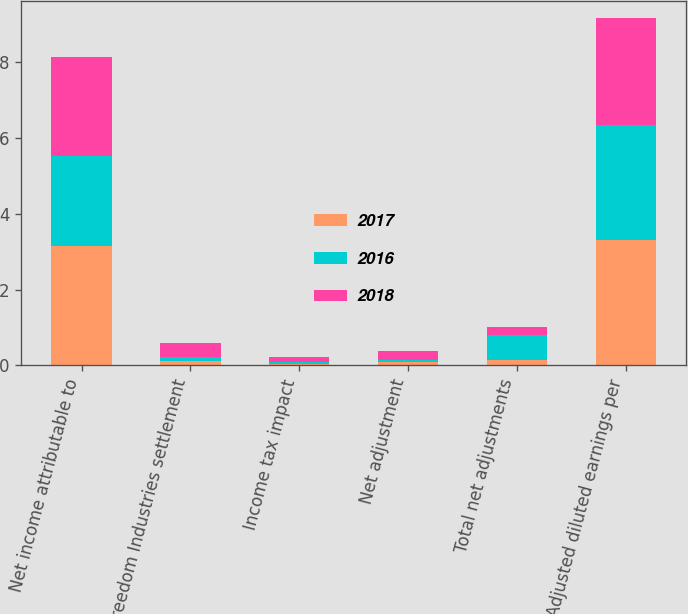Convert chart to OTSL. <chart><loc_0><loc_0><loc_500><loc_500><stacked_bar_chart><ecel><fcel>Net income attributable to<fcel>Freedom Industries settlement<fcel>Income tax impact<fcel>Net adjustment<fcel>Total net adjustments<fcel>Adjusted diluted earnings per<nl><fcel>2017<fcel>3.15<fcel>0.11<fcel>0.03<fcel>0.08<fcel>0.15<fcel>3.3<nl><fcel>2016<fcel>2.38<fcel>0.12<fcel>0.05<fcel>0.07<fcel>0.65<fcel>3.03<nl><fcel>2018<fcel>2.62<fcel>0.36<fcel>0.14<fcel>0.22<fcel>0.22<fcel>2.84<nl></chart> 